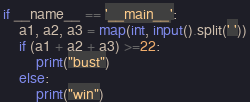Convert code to text. <code><loc_0><loc_0><loc_500><loc_500><_Python_>
if __name__ == '__main__':
    a1, a2, a3 = map(int, input().split(' '))
    if (a1 + a2 + a3) >=22:
        print("bust")
    else:
        print("win")</code> 